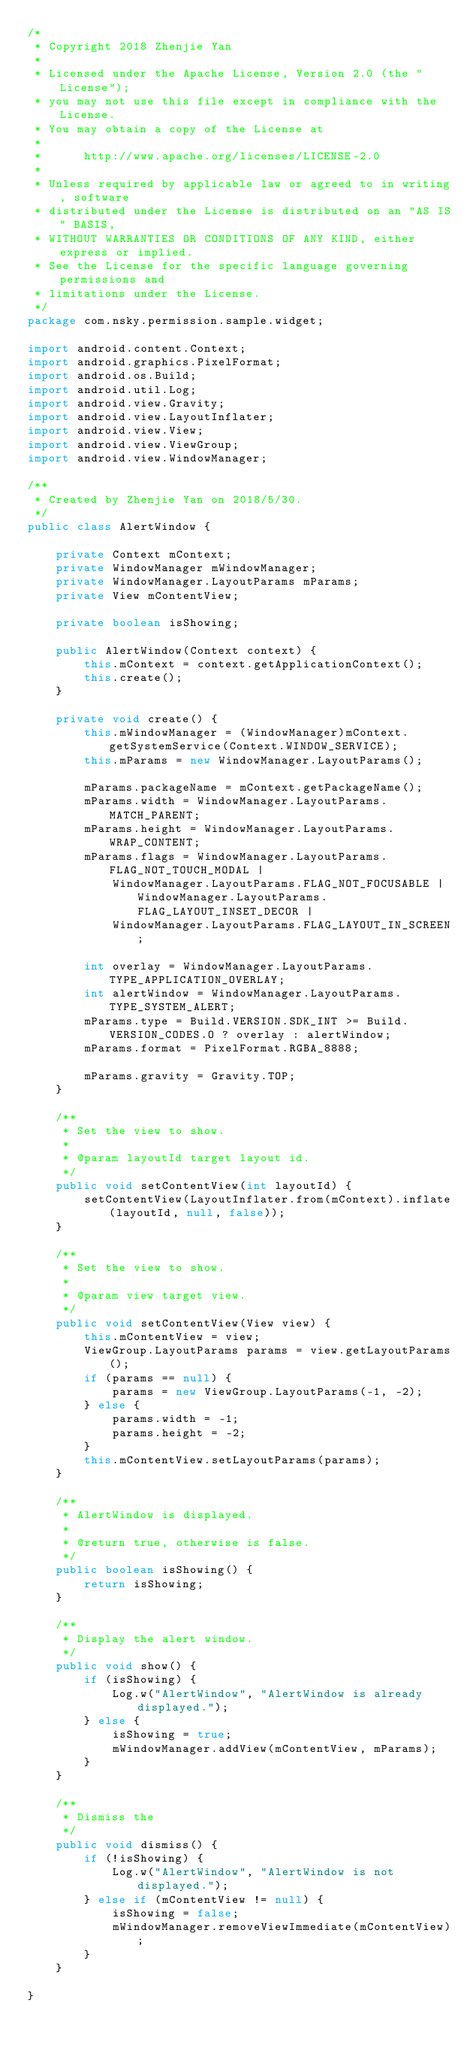<code> <loc_0><loc_0><loc_500><loc_500><_Java_>/*
 * Copyright 2018 Zhenjie Yan
 *
 * Licensed under the Apache License, Version 2.0 (the "License");
 * you may not use this file except in compliance with the License.
 * You may obtain a copy of the License at
 *
 *      http://www.apache.org/licenses/LICENSE-2.0
 *
 * Unless required by applicable law or agreed to in writing, software
 * distributed under the License is distributed on an "AS IS" BASIS,
 * WITHOUT WARRANTIES OR CONDITIONS OF ANY KIND, either express or implied.
 * See the License for the specific language governing permissions and
 * limitations under the License.
 */
package com.nsky.permission.sample.widget;

import android.content.Context;
import android.graphics.PixelFormat;
import android.os.Build;
import android.util.Log;
import android.view.Gravity;
import android.view.LayoutInflater;
import android.view.View;
import android.view.ViewGroup;
import android.view.WindowManager;

/**
 * Created by Zhenjie Yan on 2018/5/30.
 */
public class AlertWindow {

    private Context mContext;
    private WindowManager mWindowManager;
    private WindowManager.LayoutParams mParams;
    private View mContentView;

    private boolean isShowing;

    public AlertWindow(Context context) {
        this.mContext = context.getApplicationContext();
        this.create();
    }

    private void create() {
        this.mWindowManager = (WindowManager)mContext.getSystemService(Context.WINDOW_SERVICE);
        this.mParams = new WindowManager.LayoutParams();

        mParams.packageName = mContext.getPackageName();
        mParams.width = WindowManager.LayoutParams.MATCH_PARENT;
        mParams.height = WindowManager.LayoutParams.WRAP_CONTENT;
        mParams.flags = WindowManager.LayoutParams.FLAG_NOT_TOUCH_MODAL |
            WindowManager.LayoutParams.FLAG_NOT_FOCUSABLE | WindowManager.LayoutParams.FLAG_LAYOUT_INSET_DECOR |
            WindowManager.LayoutParams.FLAG_LAYOUT_IN_SCREEN;

        int overlay = WindowManager.LayoutParams.TYPE_APPLICATION_OVERLAY;
        int alertWindow = WindowManager.LayoutParams.TYPE_SYSTEM_ALERT;
        mParams.type = Build.VERSION.SDK_INT >= Build.VERSION_CODES.O ? overlay : alertWindow;
        mParams.format = PixelFormat.RGBA_8888;

        mParams.gravity = Gravity.TOP;
    }

    /**
     * Set the view to show.
     *
     * @param layoutId target layout id.
     */
    public void setContentView(int layoutId) {
        setContentView(LayoutInflater.from(mContext).inflate(layoutId, null, false));
    }

    /**
     * Set the view to show.
     *
     * @param view target view.
     */
    public void setContentView(View view) {
        this.mContentView = view;
        ViewGroup.LayoutParams params = view.getLayoutParams();
        if (params == null) {
            params = new ViewGroup.LayoutParams(-1, -2);
        } else {
            params.width = -1;
            params.height = -2;
        }
        this.mContentView.setLayoutParams(params);
    }

    /**
     * AlertWindow is displayed.
     *
     * @return true, otherwise is false.
     */
    public boolean isShowing() {
        return isShowing;
    }

    /**
     * Display the alert window.
     */
    public void show() {
        if (isShowing) {
            Log.w("AlertWindow", "AlertWindow is already displayed.");
        } else {
            isShowing = true;
            mWindowManager.addView(mContentView, mParams);
        }
    }

    /**
     * Dismiss the
     */
    public void dismiss() {
        if (!isShowing) {
            Log.w("AlertWindow", "AlertWindow is not displayed.");
        } else if (mContentView != null) {
            isShowing = false;
            mWindowManager.removeViewImmediate(mContentView);
        }
    }

}</code> 